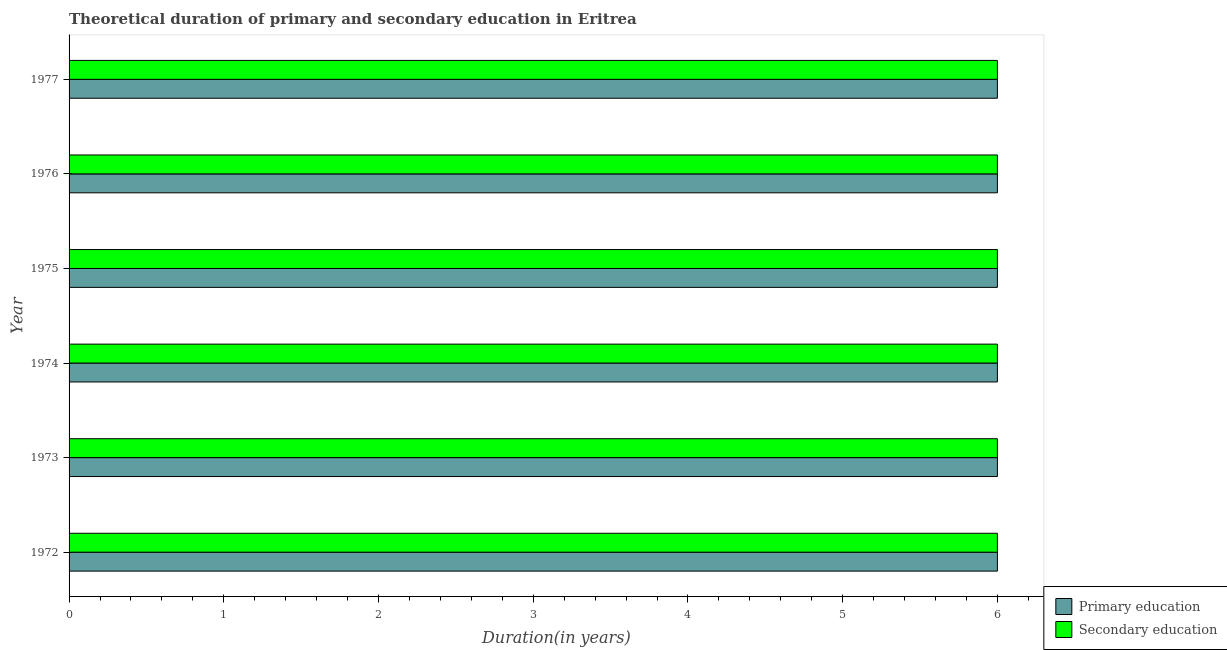Are the number of bars on each tick of the Y-axis equal?
Provide a short and direct response. Yes. How many bars are there on the 2nd tick from the top?
Make the answer very short. 2. What is the label of the 4th group of bars from the top?
Your response must be concise. 1974. In how many cases, is the number of bars for a given year not equal to the number of legend labels?
Ensure brevity in your answer.  0. What is the duration of primary education in 1972?
Offer a terse response. 6. Across all years, what is the maximum duration of secondary education?
Give a very brief answer. 6. In which year was the duration of secondary education minimum?
Give a very brief answer. 1972. What is the total duration of secondary education in the graph?
Provide a short and direct response. 36. Is the difference between the duration of secondary education in 1972 and 1977 greater than the difference between the duration of primary education in 1972 and 1977?
Offer a terse response. No. What is the difference between the highest and the second highest duration of primary education?
Your response must be concise. 0. In how many years, is the duration of secondary education greater than the average duration of secondary education taken over all years?
Provide a short and direct response. 0. What does the 2nd bar from the top in 1975 represents?
Your answer should be compact. Primary education. How many bars are there?
Offer a terse response. 12. How many years are there in the graph?
Your response must be concise. 6. Does the graph contain any zero values?
Provide a short and direct response. No. How many legend labels are there?
Offer a terse response. 2. How are the legend labels stacked?
Offer a terse response. Vertical. What is the title of the graph?
Provide a succinct answer. Theoretical duration of primary and secondary education in Eritrea. Does "Female entrants" appear as one of the legend labels in the graph?
Keep it short and to the point. No. What is the label or title of the X-axis?
Keep it short and to the point. Duration(in years). What is the label or title of the Y-axis?
Give a very brief answer. Year. What is the Duration(in years) of Primary education in 1973?
Give a very brief answer. 6. What is the Duration(in years) of Secondary education in 1973?
Give a very brief answer. 6. What is the Duration(in years) in Primary education in 1976?
Ensure brevity in your answer.  6. What is the Duration(in years) of Primary education in 1977?
Your response must be concise. 6. What is the Duration(in years) of Secondary education in 1977?
Provide a short and direct response. 6. Across all years, what is the maximum Duration(in years) of Secondary education?
Your answer should be very brief. 6. Across all years, what is the minimum Duration(in years) in Secondary education?
Provide a short and direct response. 6. What is the total Duration(in years) of Primary education in the graph?
Your response must be concise. 36. What is the total Duration(in years) of Secondary education in the graph?
Give a very brief answer. 36. What is the difference between the Duration(in years) in Secondary education in 1972 and that in 1973?
Make the answer very short. 0. What is the difference between the Duration(in years) of Secondary education in 1972 and that in 1975?
Make the answer very short. 0. What is the difference between the Duration(in years) of Secondary education in 1972 and that in 1976?
Ensure brevity in your answer.  0. What is the difference between the Duration(in years) of Primary education in 1972 and that in 1977?
Provide a succinct answer. 0. What is the difference between the Duration(in years) in Primary education in 1973 and that in 1974?
Make the answer very short. 0. What is the difference between the Duration(in years) of Primary education in 1973 and that in 1975?
Ensure brevity in your answer.  0. What is the difference between the Duration(in years) in Secondary education in 1973 and that in 1977?
Your answer should be very brief. 0. What is the difference between the Duration(in years) in Primary education in 1974 and that in 1977?
Make the answer very short. 0. What is the difference between the Duration(in years) in Secondary education in 1974 and that in 1977?
Ensure brevity in your answer.  0. What is the difference between the Duration(in years) of Secondary education in 1975 and that in 1976?
Provide a succinct answer. 0. What is the difference between the Duration(in years) in Primary education in 1975 and that in 1977?
Provide a short and direct response. 0. What is the difference between the Duration(in years) of Primary education in 1972 and the Duration(in years) of Secondary education in 1973?
Make the answer very short. 0. What is the difference between the Duration(in years) in Primary education in 1972 and the Duration(in years) in Secondary education in 1975?
Provide a succinct answer. 0. What is the difference between the Duration(in years) in Primary education in 1972 and the Duration(in years) in Secondary education in 1977?
Give a very brief answer. 0. What is the difference between the Duration(in years) of Primary education in 1973 and the Duration(in years) of Secondary education in 1974?
Ensure brevity in your answer.  0. What is the difference between the Duration(in years) in Primary education in 1973 and the Duration(in years) in Secondary education in 1976?
Ensure brevity in your answer.  0. What is the difference between the Duration(in years) in Primary education in 1974 and the Duration(in years) in Secondary education in 1975?
Offer a terse response. 0. What is the difference between the Duration(in years) of Primary education in 1974 and the Duration(in years) of Secondary education in 1977?
Your answer should be compact. 0. What is the difference between the Duration(in years) of Primary education in 1975 and the Duration(in years) of Secondary education in 1976?
Offer a terse response. 0. What is the average Duration(in years) of Primary education per year?
Make the answer very short. 6. What is the average Duration(in years) of Secondary education per year?
Keep it short and to the point. 6. In the year 1972, what is the difference between the Duration(in years) in Primary education and Duration(in years) in Secondary education?
Give a very brief answer. 0. In the year 1973, what is the difference between the Duration(in years) of Primary education and Duration(in years) of Secondary education?
Offer a terse response. 0. In the year 1976, what is the difference between the Duration(in years) of Primary education and Duration(in years) of Secondary education?
Make the answer very short. 0. What is the ratio of the Duration(in years) in Primary education in 1972 to that in 1973?
Your answer should be very brief. 1. What is the ratio of the Duration(in years) of Secondary education in 1972 to that in 1973?
Provide a succinct answer. 1. What is the ratio of the Duration(in years) of Primary education in 1972 to that in 1974?
Offer a terse response. 1. What is the ratio of the Duration(in years) in Secondary education in 1972 to that in 1974?
Your response must be concise. 1. What is the ratio of the Duration(in years) in Secondary education in 1972 to that in 1976?
Ensure brevity in your answer.  1. What is the ratio of the Duration(in years) in Secondary education in 1973 to that in 1974?
Offer a very short reply. 1. What is the ratio of the Duration(in years) of Primary education in 1973 to that in 1976?
Make the answer very short. 1. What is the ratio of the Duration(in years) in Primary education in 1973 to that in 1977?
Offer a very short reply. 1. What is the ratio of the Duration(in years) of Secondary education in 1974 to that in 1977?
Make the answer very short. 1. What is the ratio of the Duration(in years) of Primary education in 1976 to that in 1977?
Offer a terse response. 1. What is the ratio of the Duration(in years) of Secondary education in 1976 to that in 1977?
Provide a succinct answer. 1. What is the difference between the highest and the second highest Duration(in years) in Secondary education?
Make the answer very short. 0. What is the difference between the highest and the lowest Duration(in years) of Primary education?
Provide a succinct answer. 0. 